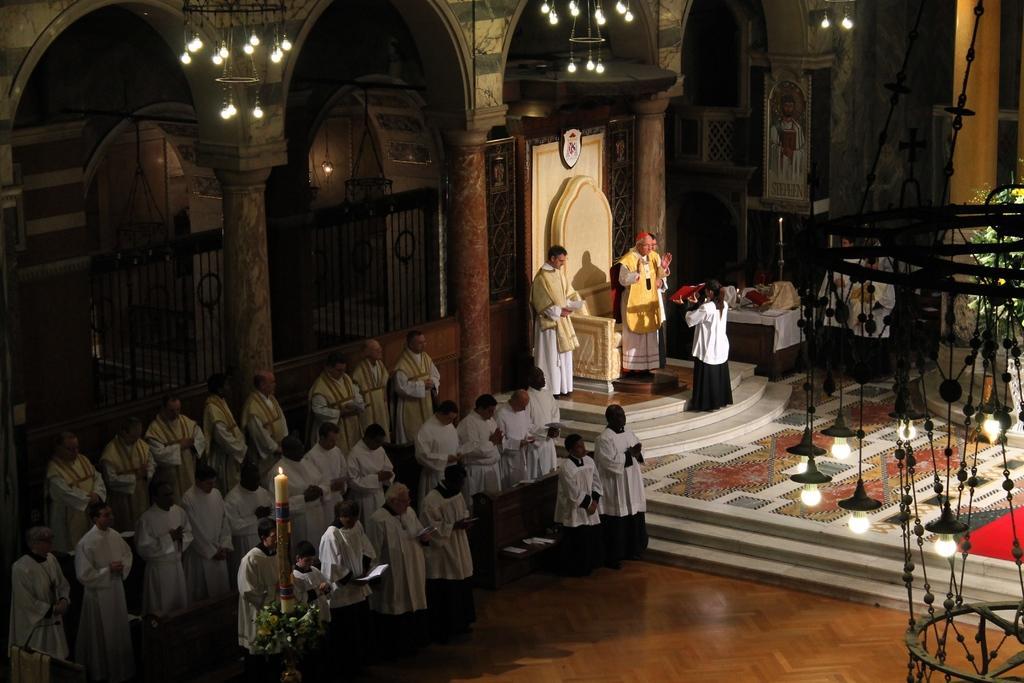Please provide a concise description of this image. In this image we can see people standing on the floor and some of them are holding books in their hands. In the background we can see grills, chandeliers, tables, candles, candle holders and carpet on the floor. 